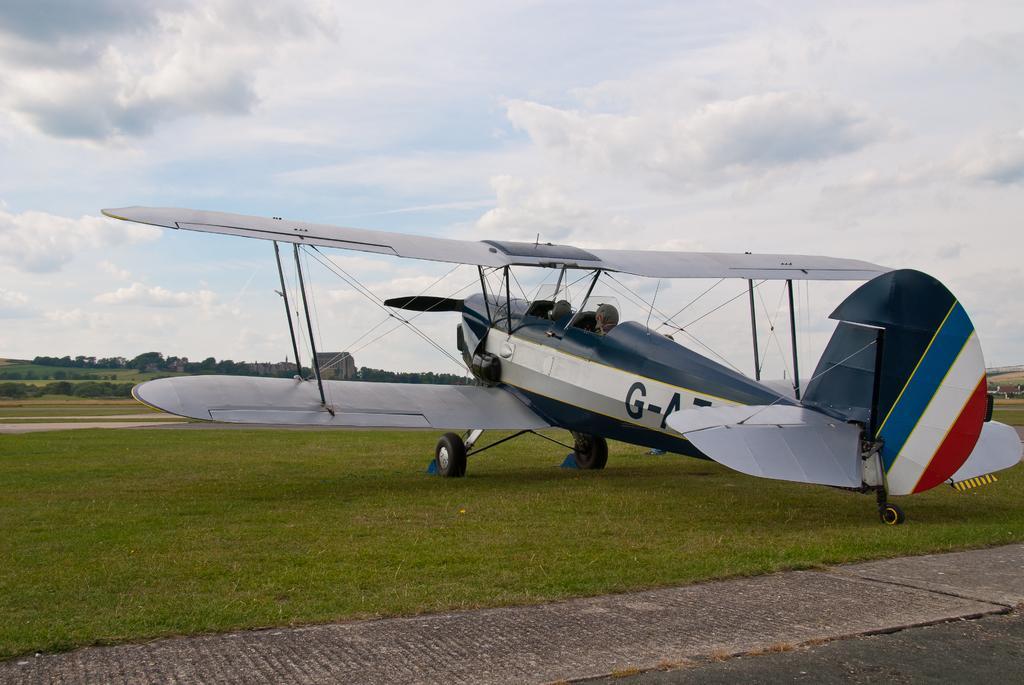Please provide a concise description of this image. In this image I can see an aeroplane which is in white,blue and red color. I can see few wheels. Back I can see trees. The sky is in white and blue color. 